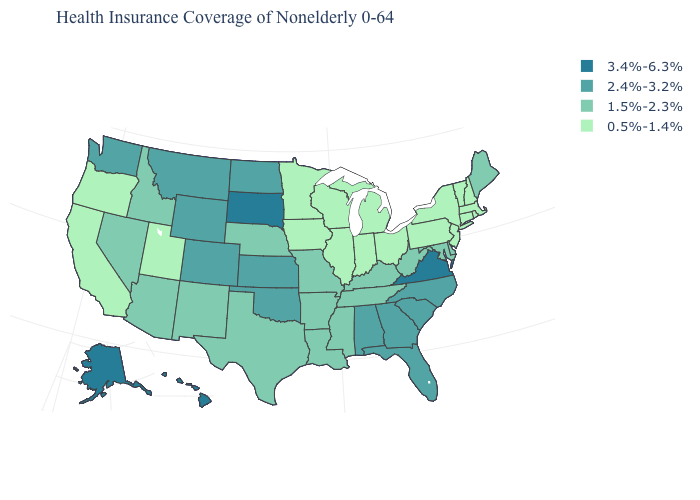How many symbols are there in the legend?
Quick response, please. 4. How many symbols are there in the legend?
Quick response, please. 4. What is the value of Oregon?
Be succinct. 0.5%-1.4%. What is the lowest value in states that border Rhode Island?
Keep it brief. 0.5%-1.4%. What is the value of California?
Quick response, please. 0.5%-1.4%. Does Nebraska have the lowest value in the MidWest?
Quick response, please. No. Among the states that border Louisiana , which have the highest value?
Concise answer only. Arkansas, Mississippi, Texas. What is the value of Alaska?
Short answer required. 3.4%-6.3%. Name the states that have a value in the range 0.5%-1.4%?
Concise answer only. California, Connecticut, Illinois, Indiana, Iowa, Massachusetts, Michigan, Minnesota, New Hampshire, New Jersey, New York, Ohio, Oregon, Pennsylvania, Rhode Island, Utah, Vermont, Wisconsin. Among the states that border Idaho , which have the lowest value?
Keep it brief. Oregon, Utah. Does Indiana have the same value as West Virginia?
Give a very brief answer. No. What is the value of South Dakota?
Quick response, please. 3.4%-6.3%. What is the lowest value in the USA?
Concise answer only. 0.5%-1.4%. Which states have the lowest value in the USA?
Concise answer only. California, Connecticut, Illinois, Indiana, Iowa, Massachusetts, Michigan, Minnesota, New Hampshire, New Jersey, New York, Ohio, Oregon, Pennsylvania, Rhode Island, Utah, Vermont, Wisconsin. 